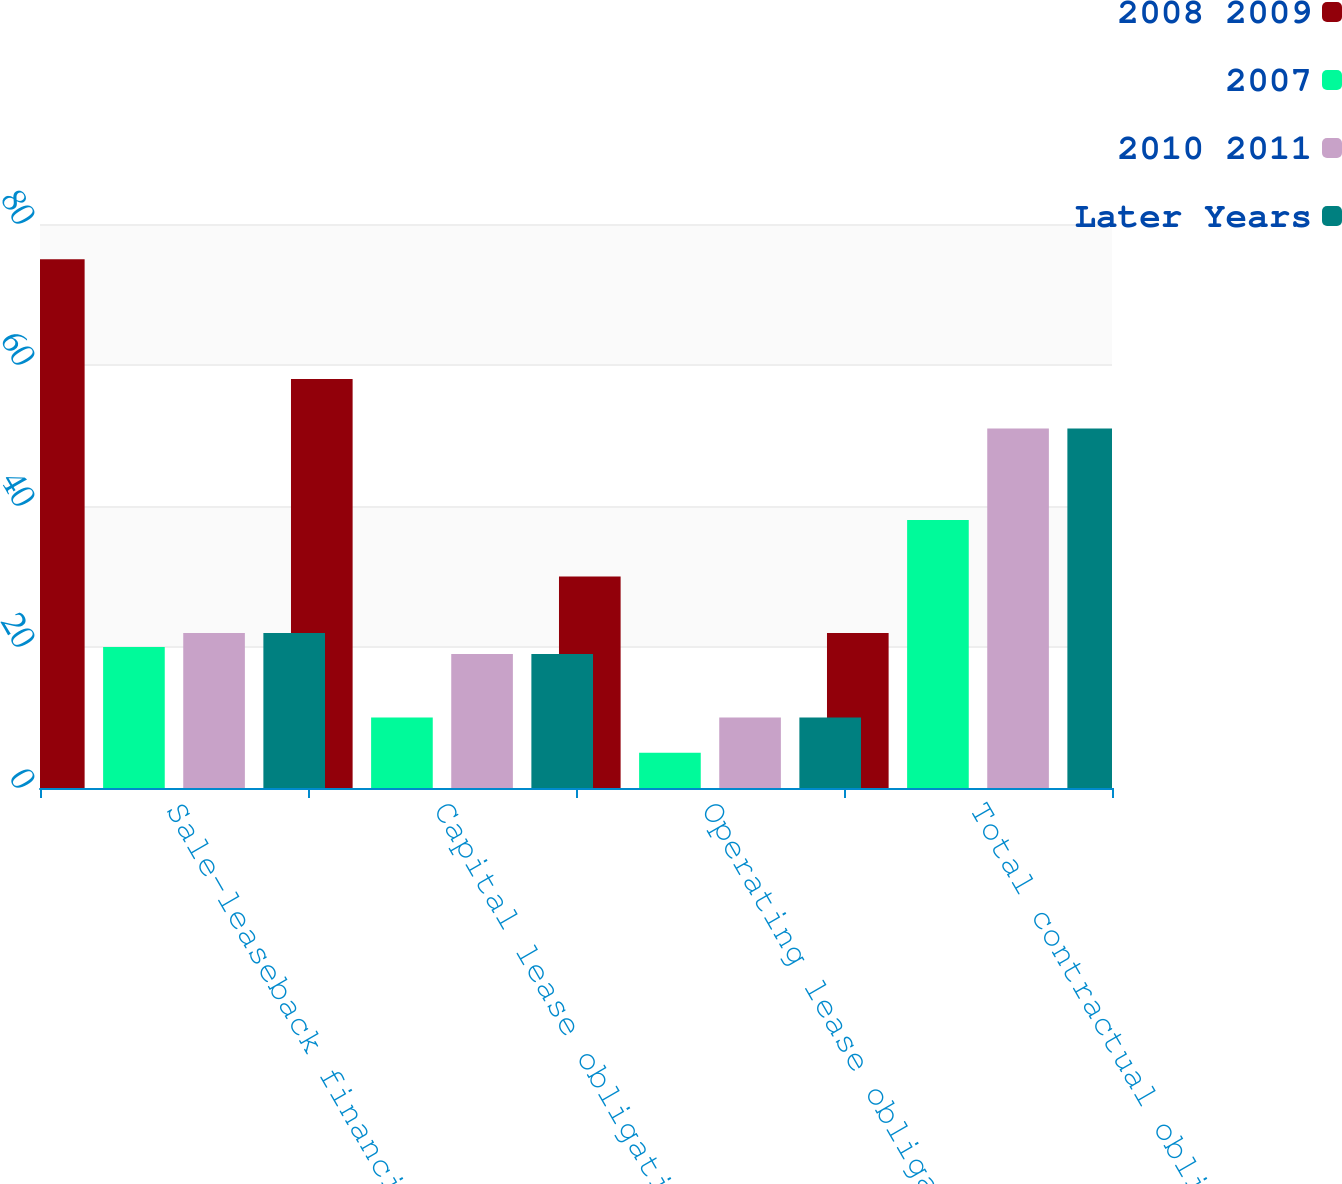<chart> <loc_0><loc_0><loc_500><loc_500><stacked_bar_chart><ecel><fcel>Sale-leaseback financing<fcel>Capital lease obligations<fcel>Operating lease obligations<fcel>Total contractual obligations<nl><fcel>2008 2009<fcel>75<fcel>58<fcel>30<fcel>22<nl><fcel>2007<fcel>20<fcel>10<fcel>5<fcel>38<nl><fcel>2010 2011<fcel>22<fcel>19<fcel>10<fcel>51<nl><fcel>Later Years<fcel>22<fcel>19<fcel>10<fcel>51<nl></chart> 